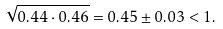<formula> <loc_0><loc_0><loc_500><loc_500>\sqrt { 0 . 4 4 \cdot 0 . 4 6 } = 0 . 4 5 \pm 0 . 0 3 < 1 .</formula> 